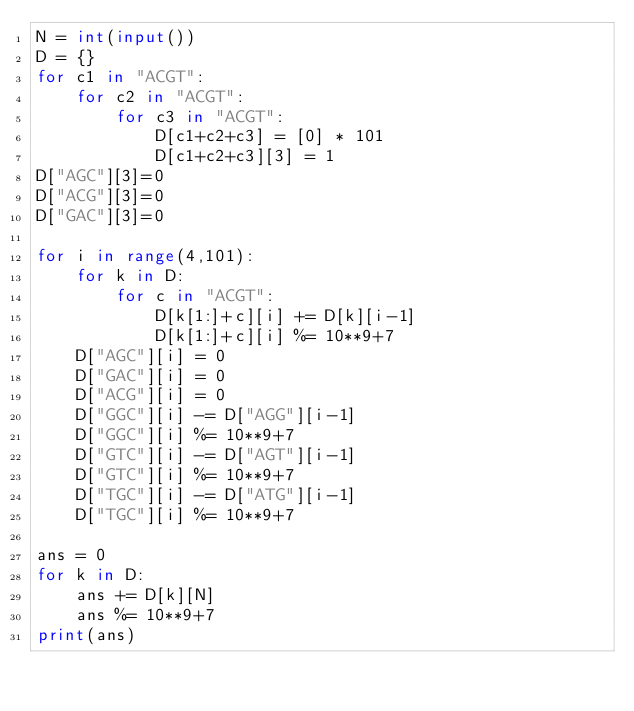Convert code to text. <code><loc_0><loc_0><loc_500><loc_500><_Python_>N = int(input())
D = {}
for c1 in "ACGT":
    for c2 in "ACGT":
        for c3 in "ACGT":
            D[c1+c2+c3] = [0] * 101
            D[c1+c2+c3][3] = 1
D["AGC"][3]=0
D["ACG"][3]=0
D["GAC"][3]=0

for i in range(4,101):
    for k in D:
        for c in "ACGT":
            D[k[1:]+c][i] += D[k][i-1]
            D[k[1:]+c][i] %= 10**9+7
    D["AGC"][i] = 0
    D["GAC"][i] = 0
    D["ACG"][i] = 0
    D["GGC"][i] -= D["AGG"][i-1]
    D["GGC"][i] %= 10**9+7
    D["GTC"][i] -= D["AGT"][i-1]
    D["GTC"][i] %= 10**9+7
    D["TGC"][i] -= D["ATG"][i-1]
    D["TGC"][i] %= 10**9+7

ans = 0
for k in D:
    ans += D[k][N]
    ans %= 10**9+7
print(ans)
</code> 